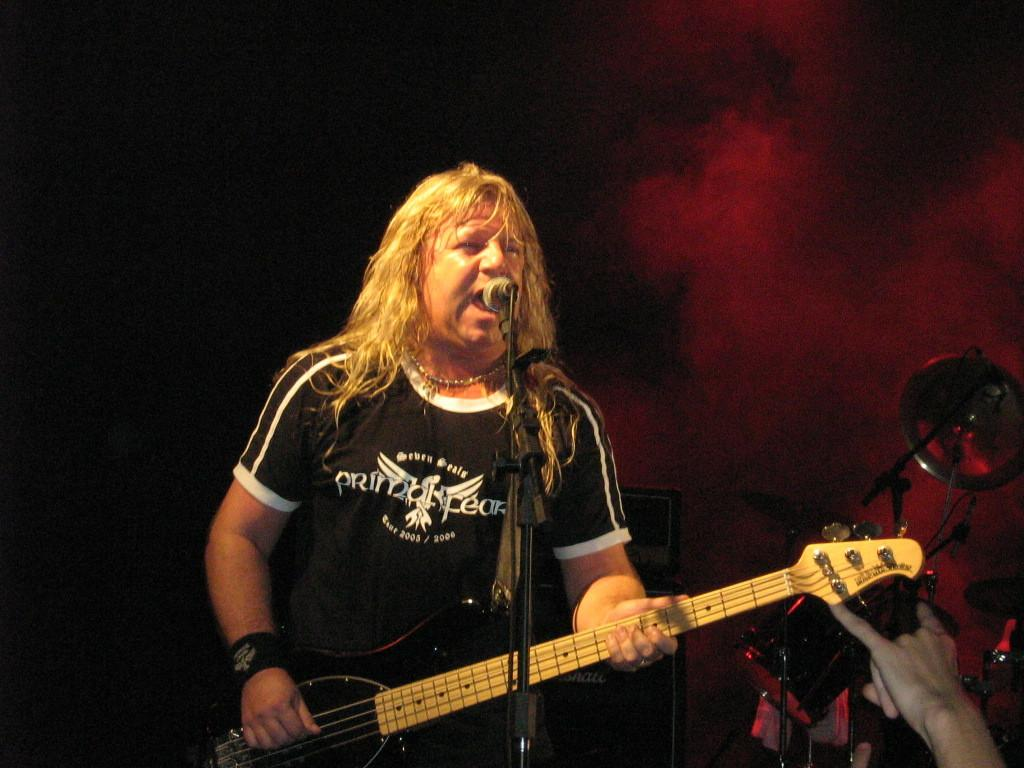Who is the main subject in the image? There is a man in the image. What is the man doing in the image? The man is standing in front of a microphone and holding a guitar. What other musical instruments can be seen in the image? There are other musical instruments visible in the image. Are there any other people visible in the image? Yes, there are hands of other people visible in the image. What type of industry is depicted in the image? There is no specific industry depicted in the image; it features a man with a guitar and other musical instruments. 